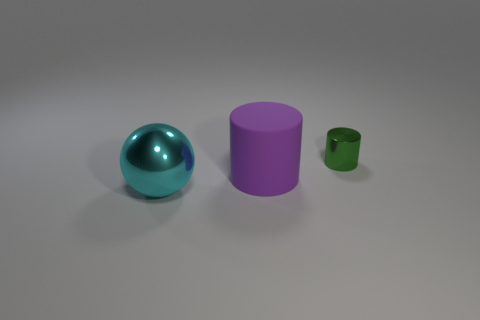Subtract 1 cylinders. How many cylinders are left? 1 Add 1 tiny metallic things. How many objects exist? 4 Subtract all cylinders. How many objects are left? 1 Add 2 small green metal objects. How many small green metal objects exist? 3 Subtract 1 purple cylinders. How many objects are left? 2 Subtract all green cylinders. Subtract all cyan cubes. How many cylinders are left? 1 Subtract all brown cubes. How many green cylinders are left? 1 Subtract all large cyan blocks. Subtract all rubber cylinders. How many objects are left? 2 Add 2 tiny metal cylinders. How many tiny metal cylinders are left? 3 